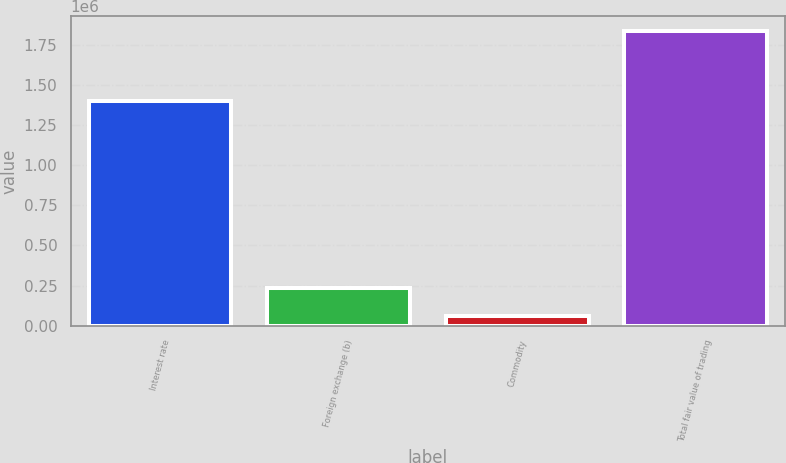Convert chart to OTSL. <chart><loc_0><loc_0><loc_500><loc_500><bar_chart><fcel>Interest rate<fcel>Foreign exchange (b)<fcel>Commodity<fcel>Total fair value of trading<nl><fcel>1.39982e+06<fcel>237675<fcel>59944<fcel>1.83726e+06<nl></chart> 